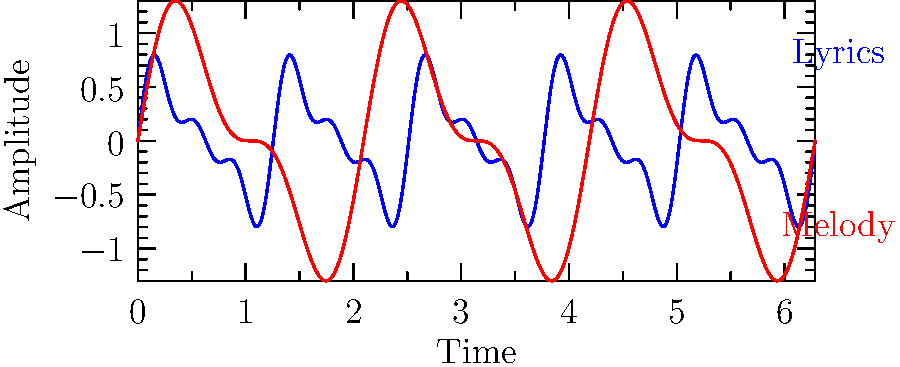Analyzing the waveform visualizations of lyrics and melody for a dance track, which element appears to have a more complex emotional impact based on the frequency and amplitude variations? To determine which element has a more complex emotional impact, we need to analyze the waveform visualizations for both lyrics and melody:

1. Lyrics waveform (blue):
   - Shows higher frequency components
   - Has more irregular patterns and rapid changes
   - Combines multiple sine waves of different frequencies
   - Amplitude variations are more frequent and less predictable

2. Melody waveform (red):
   - Displays lower frequency components
   - Has a more regular and smooth pattern
   - Consists of fewer sine wave components
   - Amplitude variations are more consistent and predictable

3. Complexity analysis:
   - Higher frequencies in lyrics suggest more words or syllables per unit time
   - Irregular patterns in lyrics indicate varied emotional content
   - Multiple frequency components in lyrics imply a richer emotional palette
   - Frequent amplitude changes in lyrics suggest more dynamic emotional expression

4. Emotional impact:
   - Complex waveforms generally correlate with more nuanced emotional content
   - Rapid changes in the lyrics' waveform indicate a higher potential for conveying varied emotions
   - The melody's smoother waveform suggests a more consistent emotional backdrop

Based on this analysis, the lyrics appear to have a more complex emotional impact due to their higher frequency components, irregular patterns, and more varied amplitude changes.
Answer: Lyrics 